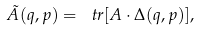Convert formula to latex. <formula><loc_0><loc_0><loc_500><loc_500>\tilde { A } ( q , p ) = \ t r [ A \cdot \Delta ( q , p ) ] ,</formula> 